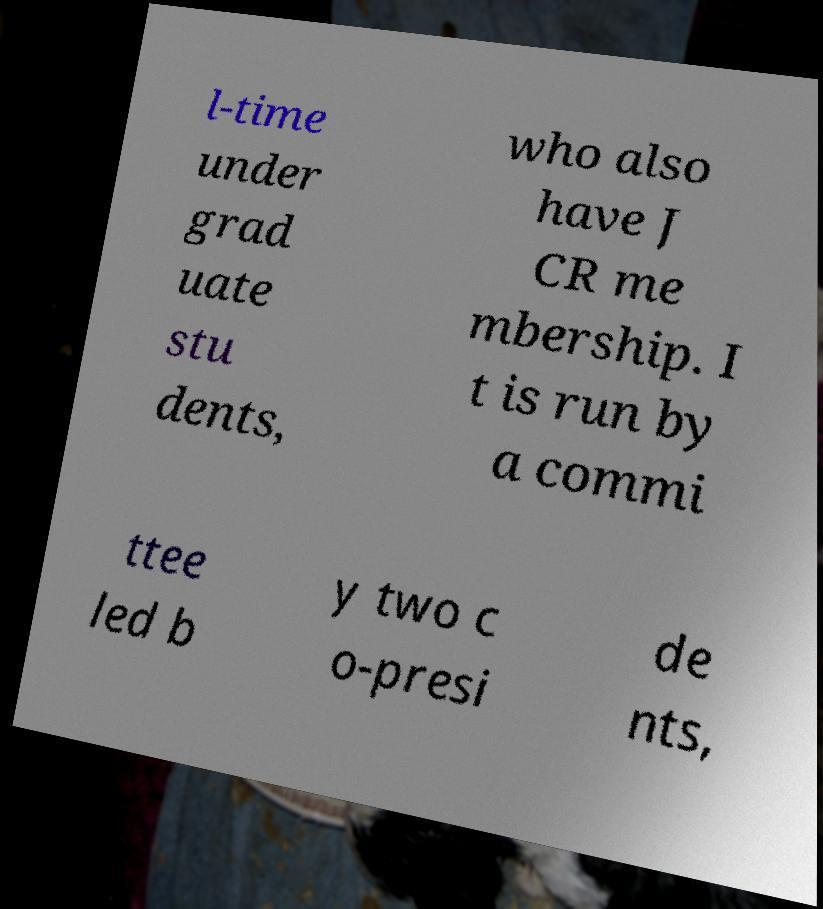Could you assist in decoding the text presented in this image and type it out clearly? l-time under grad uate stu dents, who also have J CR me mbership. I t is run by a commi ttee led b y two c o-presi de nts, 